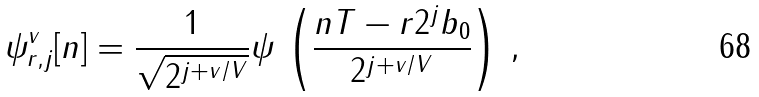<formula> <loc_0><loc_0><loc_500><loc_500>\psi _ { r , j } ^ { v } [ n ] = \frac { 1 } { \sqrt { 2 ^ { j + v / V } } } \psi \, \left ( \frac { n T - r 2 ^ { j } b _ { 0 } } { 2 ^ { j + v / V } } \right ) \, ,</formula> 